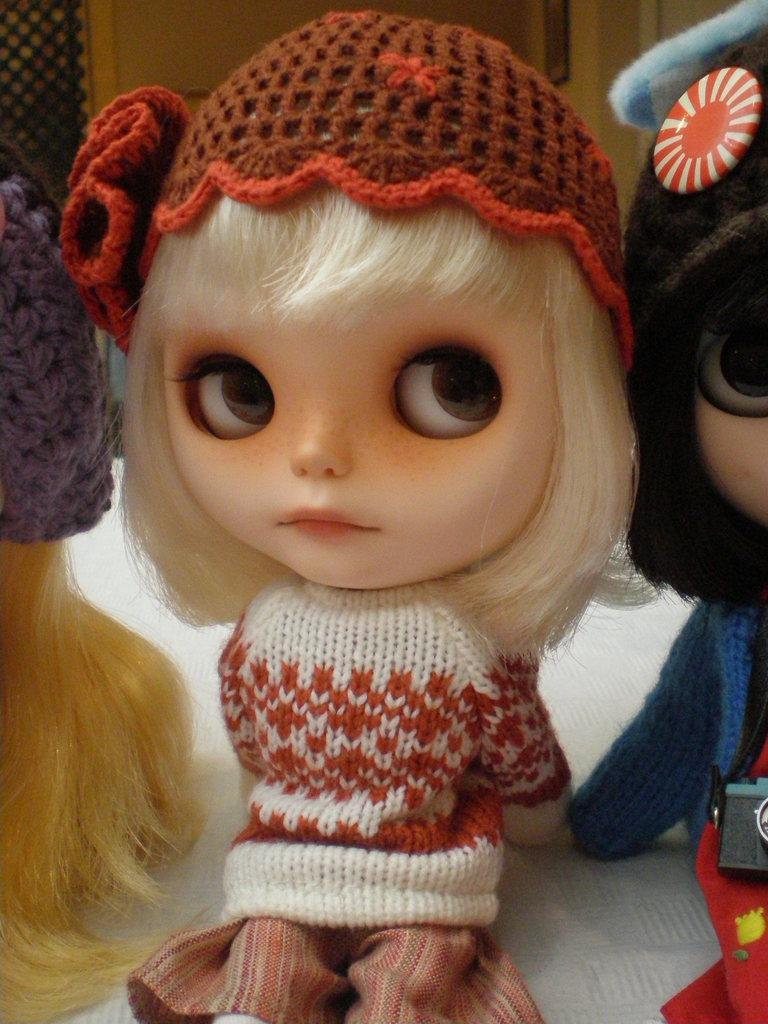What is the main subject of the image? There is a doll in the image. What is the doll wearing on its head? The doll is wearing a brown cap. What type of clothing is the doll wearing? The doll is wearing a sweater. What type of cave can be seen in the background of the image? There is no cave present in the image; it features a doll wearing a brown cap and a sweater. What type of notebook is the doll holding in the image? There is no notebook present in the image; it only shows a doll wearing a brown cap and a sweater. 